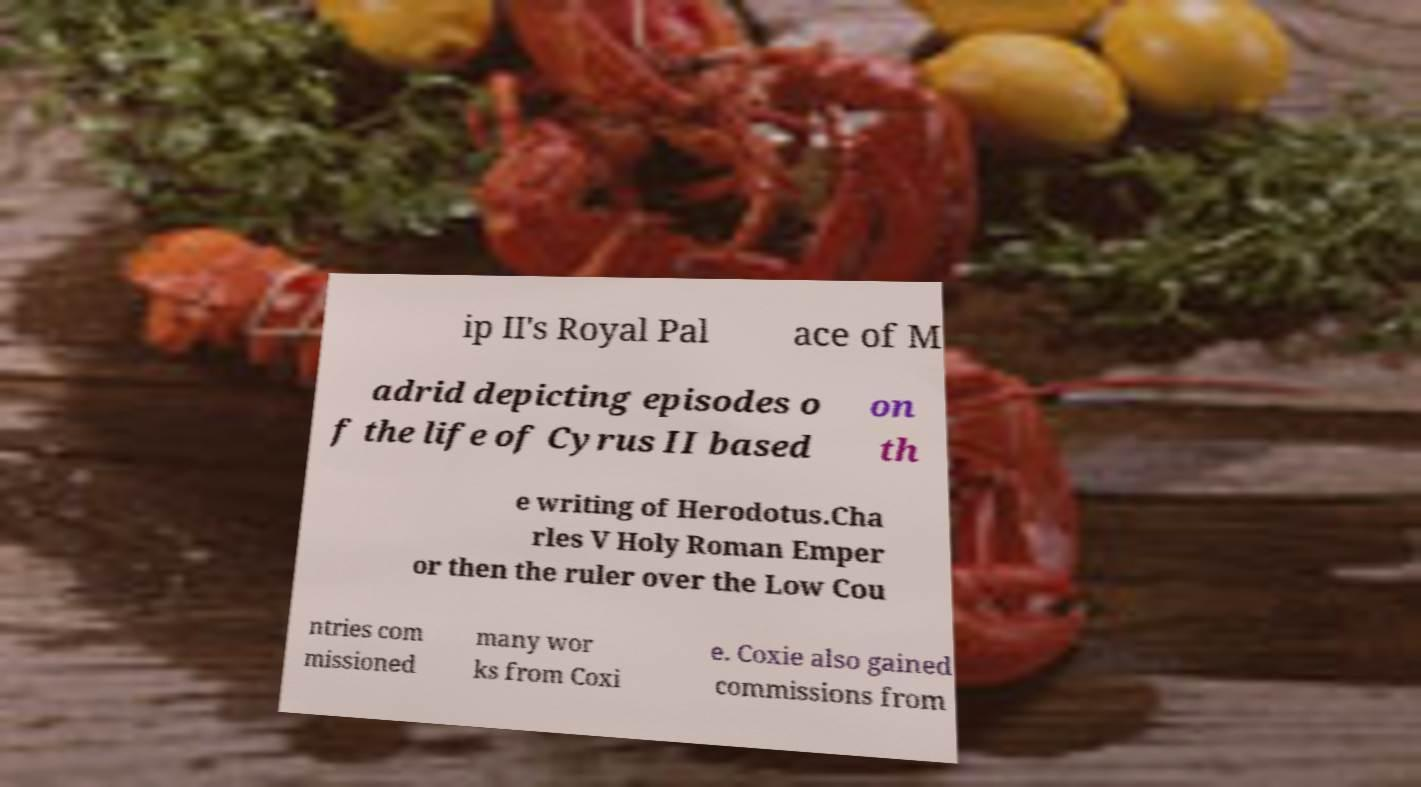Could you assist in decoding the text presented in this image and type it out clearly? ip II's Royal Pal ace of M adrid depicting episodes o f the life of Cyrus II based on th e writing of Herodotus.Cha rles V Holy Roman Emper or then the ruler over the Low Cou ntries com missioned many wor ks from Coxi e. Coxie also gained commissions from 